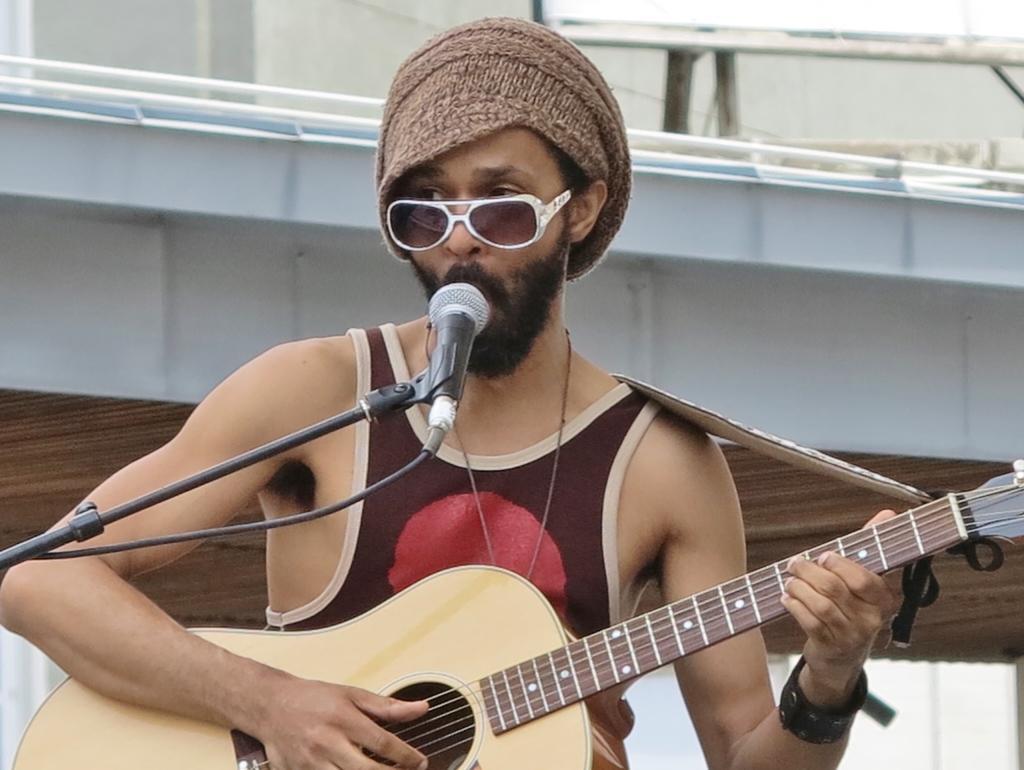Can you describe this image briefly? In the image we can see there is a man who is holding guitar in his hand and in front of him there is a mic with a stand. 